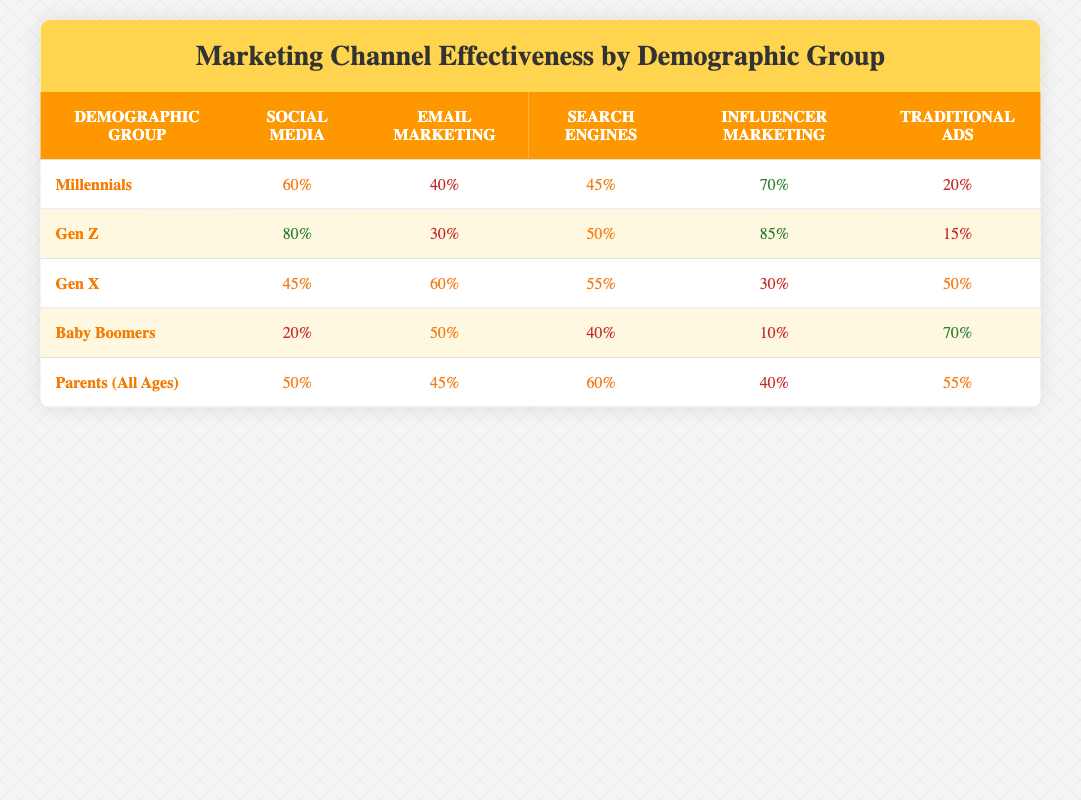What is the highest percentage for Influencer Marketing among the demographic groups? Looking at the Influencer Marketing column, Gen Z has the highest percentage at 85%.
Answer: 85% Which demographic group is least effective in Social Media marketing? In the Social Media column, Baby Boomers have the lowest value at 20%.
Answer: 20% What is the average effectiveness of Email Marketing across all demographic groups? The Email Marketing percentages are 40, 30, 60, 50, and 45. The sum is 225, and there are 5 groups. So, 225 divided by 5 is 45.
Answer: 45 Is Traditional Ads more effective for Baby Boomers than for Millennials? Baby Boomers have 70% effectiveness in Traditional Ads, while Millennials have only 20%. This means Baby Boomers' effectiveness is higher.
Answer: Yes Which demographic group has the highest combined effectiveness in Social Media and Influencer Marketing? For Millennials: 60% + 70% = 130%. For Gen Z: 80% + 85% = 165%. For Gen X: 45% + 30% = 75%. For Baby Boomers: 20% + 10% = 30%. For Parents: 50% + 40% = 90%. Gen Z has the highest combined effectiveness at 165%.
Answer: 165% What percentage of Gen X prefers Email Marketing compared to Influencer Marketing? Gen X's Email Marketing effectiveness is 60%, and Influencer Marketing is 30%. Therefore, Email Marketing is preferred as it has a higher value.
Answer: Yes Which marketing channel is most effective for Parents (All Ages)? The highest percentage in the Parents row is for Search Engines at 60%.
Answer: 60% Is there any demographic group that prefers Traditional Ads more than Social Media? Baby Boomers prefer Traditional Ads (70%) over Social Media (20%). This holds true for Baby Boomers only.
Answer: Yes What is the combined effectiveness of Email Marketing and Social Media for Gen Z? Gen Z's Email Marketing is 30% and Social Media is 80%. Adding those gives us 30% + 80% = 110%.
Answer: 110% 